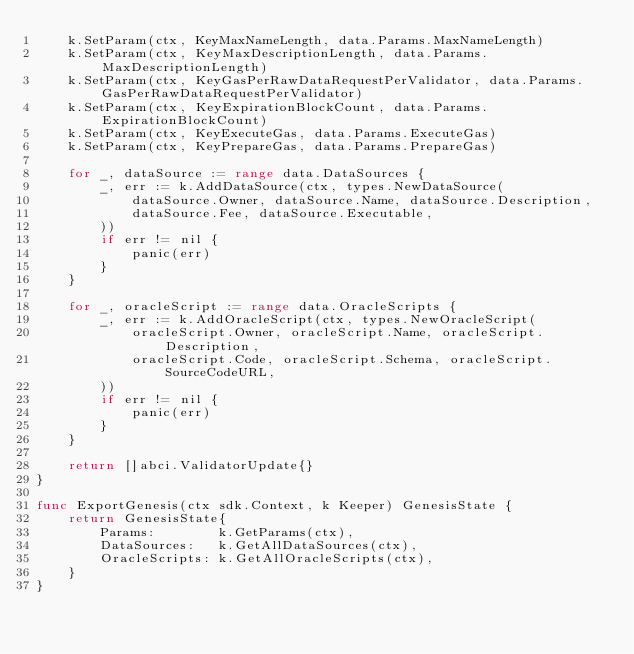Convert code to text. <code><loc_0><loc_0><loc_500><loc_500><_Go_>	k.SetParam(ctx, KeyMaxNameLength, data.Params.MaxNameLength)
	k.SetParam(ctx, KeyMaxDescriptionLength, data.Params.MaxDescriptionLength)
	k.SetParam(ctx, KeyGasPerRawDataRequestPerValidator, data.Params.GasPerRawDataRequestPerValidator)
	k.SetParam(ctx, KeyExpirationBlockCount, data.Params.ExpirationBlockCount)
	k.SetParam(ctx, KeyExecuteGas, data.Params.ExecuteGas)
	k.SetParam(ctx, KeyPrepareGas, data.Params.PrepareGas)

	for _, dataSource := range data.DataSources {
		_, err := k.AddDataSource(ctx, types.NewDataSource(
			dataSource.Owner, dataSource.Name, dataSource.Description,
			dataSource.Fee, dataSource.Executable,
		))
		if err != nil {
			panic(err)
		}
	}

	for _, oracleScript := range data.OracleScripts {
		_, err := k.AddOracleScript(ctx, types.NewOracleScript(
			oracleScript.Owner, oracleScript.Name, oracleScript.Description,
			oracleScript.Code, oracleScript.Schema, oracleScript.SourceCodeURL,
		))
		if err != nil {
			panic(err)
		}
	}

	return []abci.ValidatorUpdate{}
}

func ExportGenesis(ctx sdk.Context, k Keeper) GenesisState {
	return GenesisState{
		Params:        k.GetParams(ctx),
		DataSources:   k.GetAllDataSources(ctx),
		OracleScripts: k.GetAllOracleScripts(ctx),
	}
}
</code> 